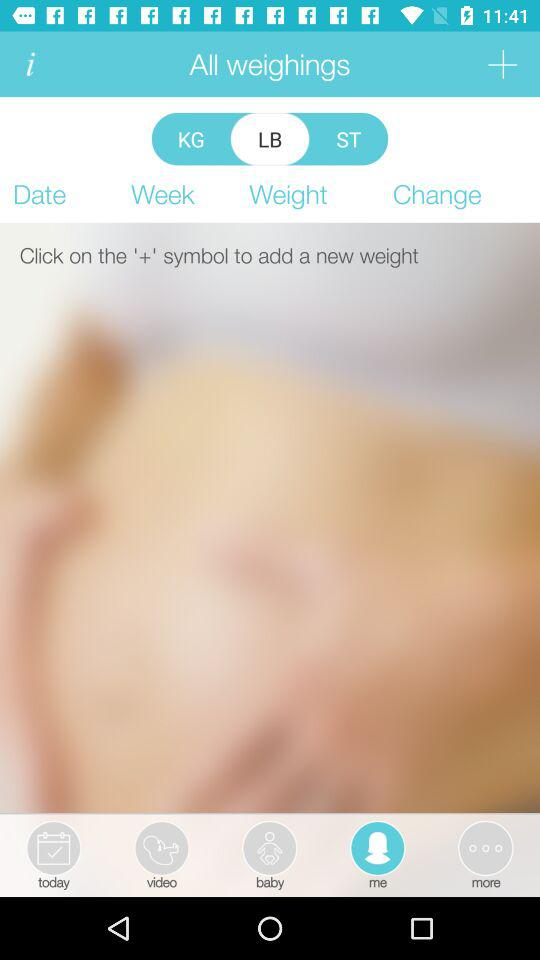Which unit is selected for weight? The selected unit for weight is "LB". 